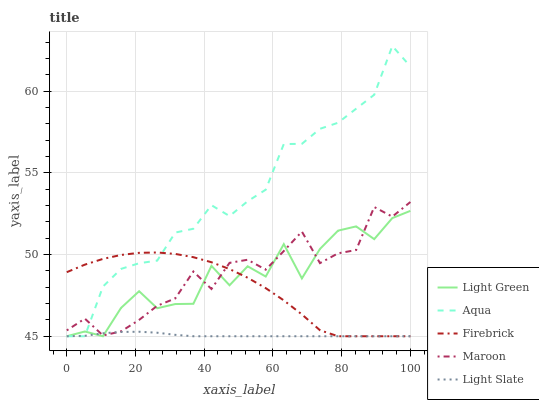Does Light Slate have the minimum area under the curve?
Answer yes or no. Yes. Does Aqua have the maximum area under the curve?
Answer yes or no. Yes. Does Firebrick have the minimum area under the curve?
Answer yes or no. No. Does Firebrick have the maximum area under the curve?
Answer yes or no. No. Is Light Slate the smoothest?
Answer yes or no. Yes. Is Light Green the roughest?
Answer yes or no. Yes. Is Firebrick the smoothest?
Answer yes or no. No. Is Firebrick the roughest?
Answer yes or no. No. Does Light Slate have the lowest value?
Answer yes or no. Yes. Does Maroon have the lowest value?
Answer yes or no. No. Does Aqua have the highest value?
Answer yes or no. Yes. Does Firebrick have the highest value?
Answer yes or no. No. Does Firebrick intersect Maroon?
Answer yes or no. Yes. Is Firebrick less than Maroon?
Answer yes or no. No. Is Firebrick greater than Maroon?
Answer yes or no. No. 